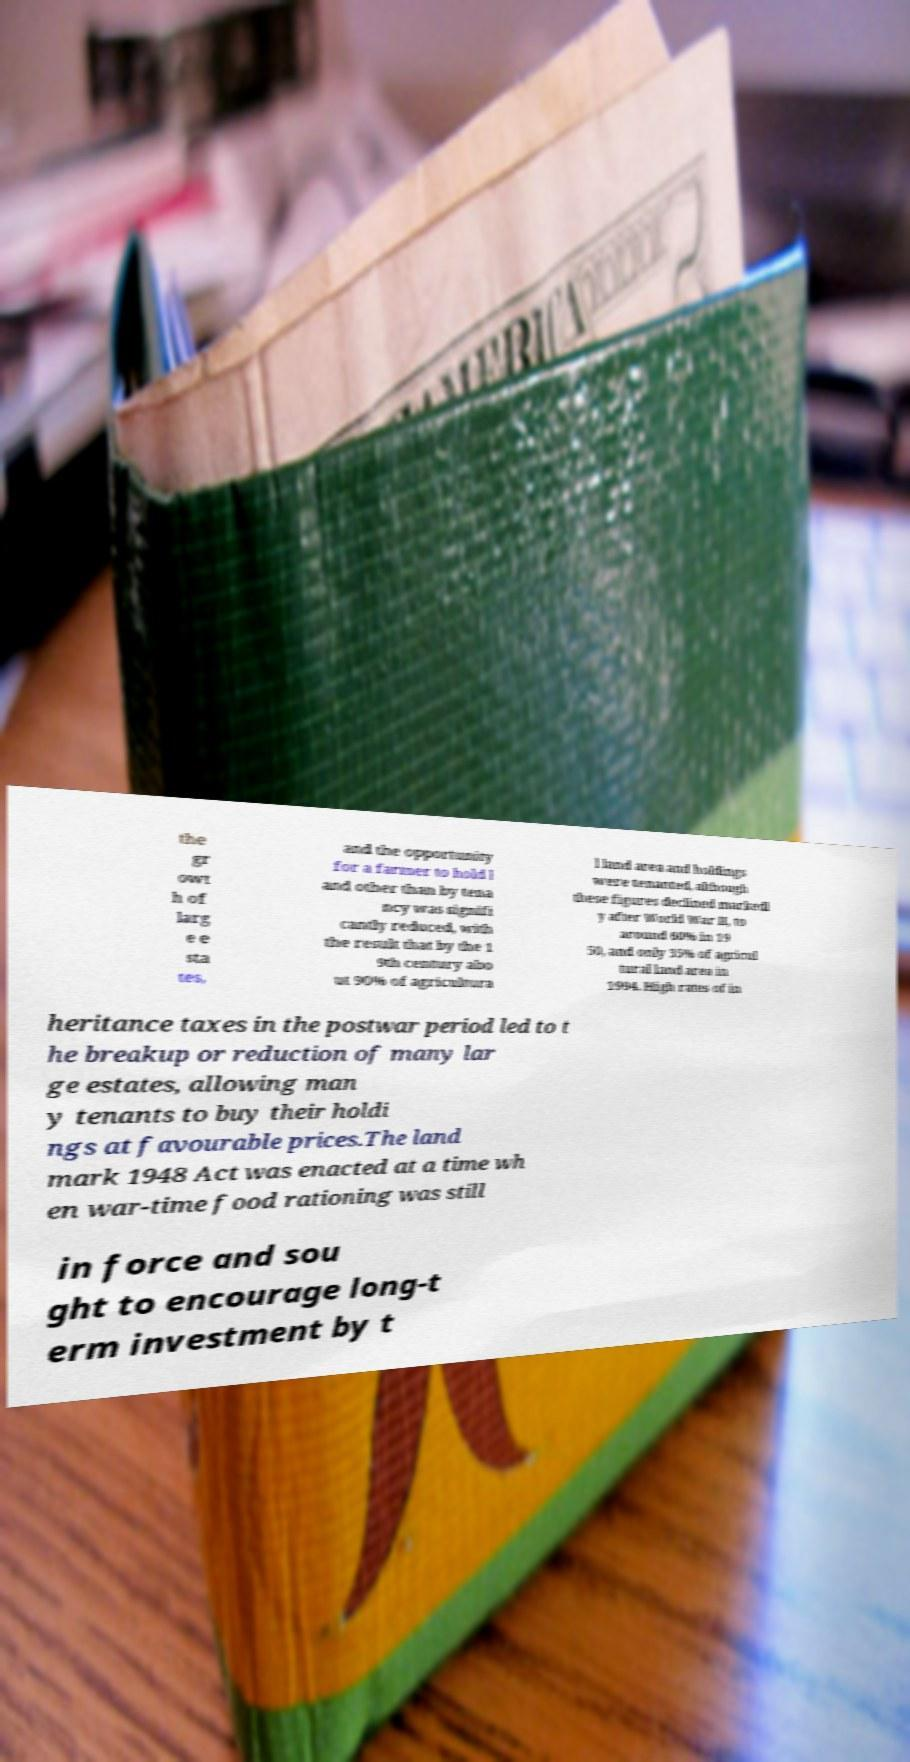There's text embedded in this image that I need extracted. Can you transcribe it verbatim? the gr owt h of larg e e sta tes, and the opportunity for a farmer to hold l and other than by tena ncy was signifi cantly reduced, with the result that by the 1 9th century abo ut 90% of agricultura l land area and holdings were tenanted, although these figures declined markedl y after World War II, to around 60% in 19 50, and only 35% of agricul tural land area in 1994. High rates of in heritance taxes in the postwar period led to t he breakup or reduction of many lar ge estates, allowing man y tenants to buy their holdi ngs at favourable prices.The land mark 1948 Act was enacted at a time wh en war-time food rationing was still in force and sou ght to encourage long-t erm investment by t 